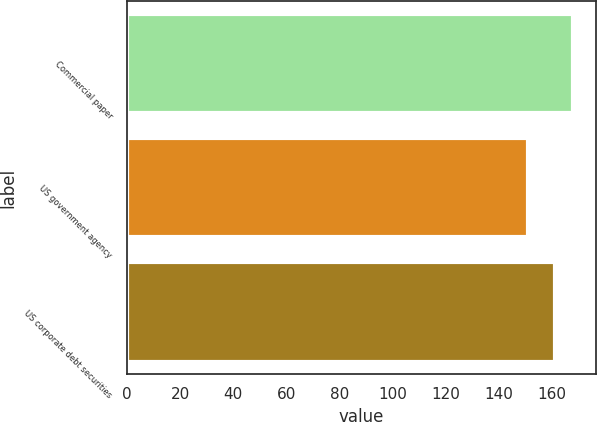Convert chart to OTSL. <chart><loc_0><loc_0><loc_500><loc_500><bar_chart><fcel>Commercial paper<fcel>US government agency<fcel>US corporate debt securities<nl><fcel>168<fcel>151<fcel>161<nl></chart> 